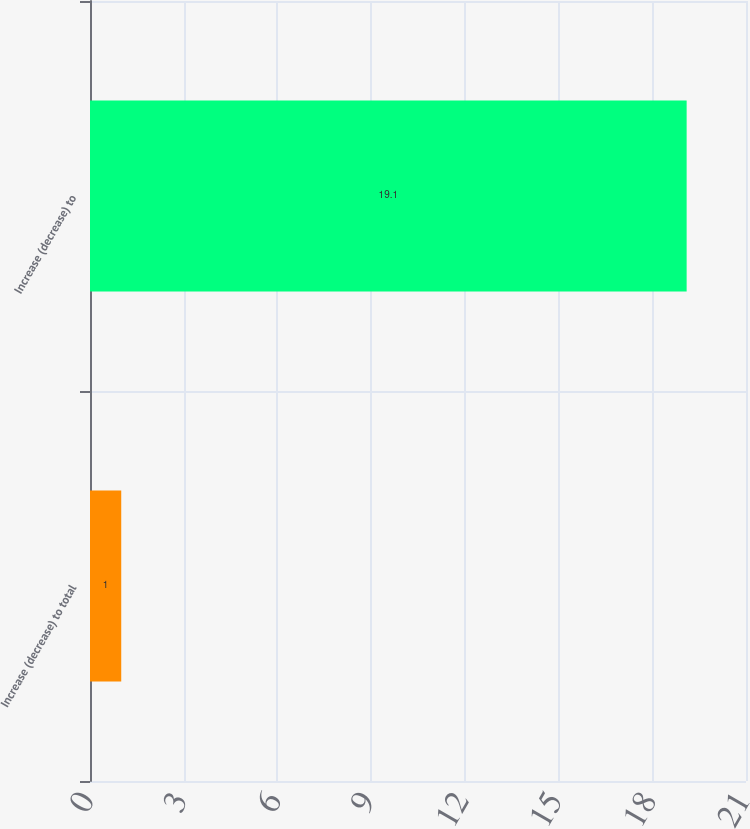<chart> <loc_0><loc_0><loc_500><loc_500><bar_chart><fcel>Increase (decrease) to total<fcel>Increase (decrease) to<nl><fcel>1<fcel>19.1<nl></chart> 